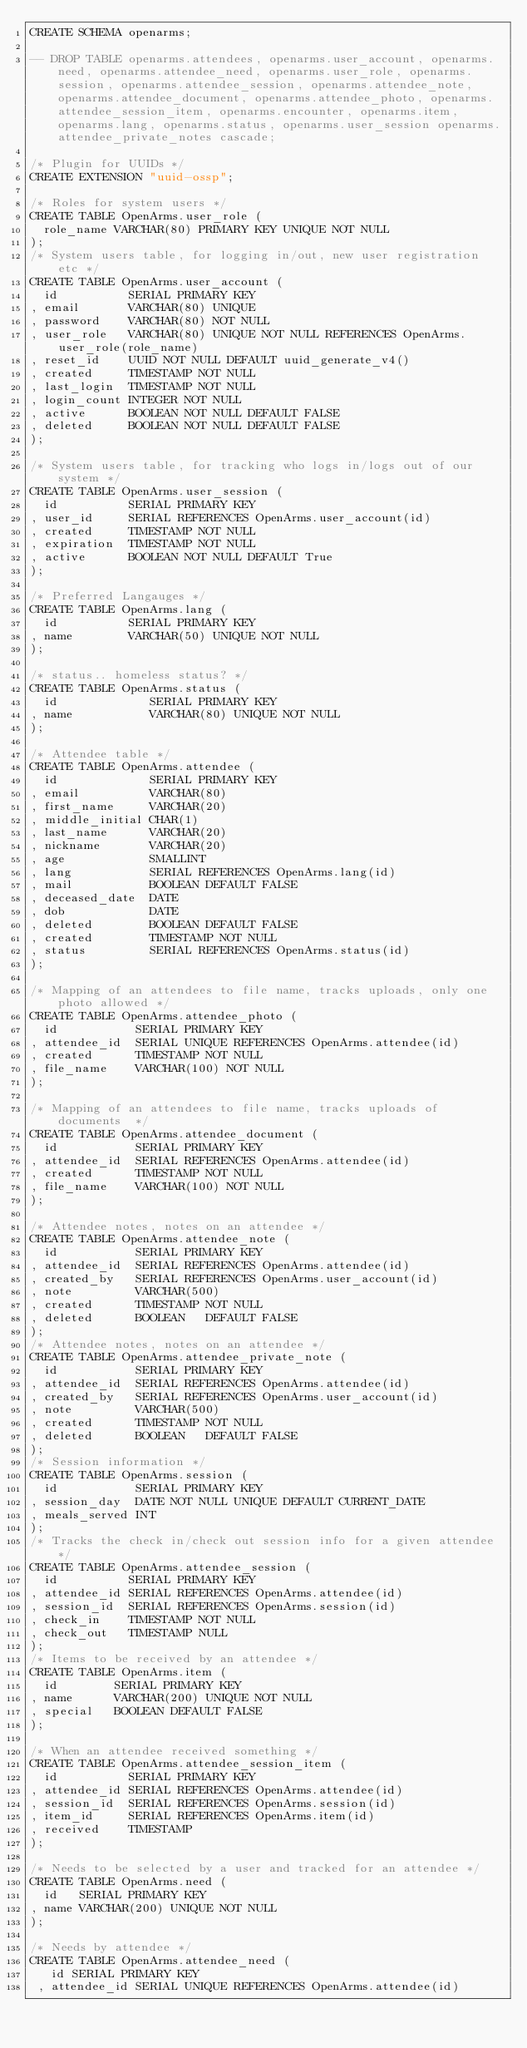Convert code to text. <code><loc_0><loc_0><loc_500><loc_500><_SQL_>CREATE SCHEMA openarms;

-- DROP TABLE openarms.attendees, openarms.user_account, openarms.need, openarms.attendee_need, openarms.user_role, openarms.session, openarms.attendee_session, openarms.attendee_note, openarms.attendee_document, openarms.attendee_photo, openarms.attendee_session_item, openarms.encounter, openarms.item, openarms.lang, openarms.status, openarms.user_session openarms.attendee_private_notes cascade;

/* Plugin for UUIDs */
CREATE EXTENSION "uuid-ossp";

/* Roles for system users */
CREATE TABLE OpenArms.user_role (
  role_name VARCHAR(80) PRIMARY KEY UNIQUE NOT NULL
);
/* System users table, for logging in/out, new user registration etc */
CREATE TABLE OpenArms.user_account (
  id          SERIAL PRIMARY KEY
, email       VARCHAR(80) UNIQUE
, password    VARCHAR(80) NOT NULL
, user_role   VARCHAR(80) UNIQUE NOT NULL REFERENCES OpenArms.user_role(role_name) 
, reset_id    UUID NOT NULL DEFAULT uuid_generate_v4()
, created     TIMESTAMP NOT NULL
, last_login  TIMESTAMP NOT NULL
, login_count INTEGER NOT NULL 
, active      BOOLEAN NOT NULL DEFAULT FALSE
, deleted     BOOLEAN NOT NULL DEFAULT FALSE
);

/* System users table, for tracking who logs in/logs out of our system */
CREATE TABLE OpenArms.user_session (
  id          SERIAL PRIMARY KEY
, user_id     SERIAL REFERENCES OpenArms.user_account(id)
, created     TIMESTAMP NOT NULL
, expiration  TIMESTAMP NOT NULL
, active      BOOLEAN NOT NULL DEFAULT True
);

/* Preferred Langauges */
CREATE TABLE OpenArms.lang (
  id          SERIAL PRIMARY KEY
, name        VARCHAR(50) UNIQUE NOT NULL
);

/* status.. homeless status? */ 
CREATE TABLE OpenArms.status (
  id             SERIAL PRIMARY KEY 
, name           VARCHAR(80) UNIQUE NOT NULL
);

/* Attendee table */
CREATE TABLE OpenArms.attendee (
  id             SERIAL PRIMARY KEY 
, email          VARCHAR(80) 
, first_name     VARCHAR(20) 
, middle_initial CHAR(1) 
, last_name      VARCHAR(20) 
, nickname       VARCHAR(20) 
, age            SMALLINT
, lang           SERIAL REFERENCES OpenArms.lang(id)
, mail           BOOLEAN DEFAULT FALSE
, deceased_date  DATE
, dob            DATE 
, deleted        BOOLEAN DEFAULT FALSE
, created        TIMESTAMP NOT NULL
, status         SERIAL REFERENCES OpenArms.status(id)
);

/* Mapping of an attendees to file name, tracks uploads, only one photo allowed */
CREATE TABLE OpenArms.attendee_photo (
  id           SERIAL PRIMARY KEY
, attendee_id  SERIAL UNIQUE REFERENCES OpenArms.attendee(id)
, created      TIMESTAMP NOT NULL
, file_name    VARCHAR(100) NOT NULL
);

/* Mapping of an attendees to file name, tracks uploads of documents  */
CREATE TABLE OpenArms.attendee_document (
  id           SERIAL PRIMARY KEY
, attendee_id  SERIAL REFERENCES OpenArms.attendee(id)
, created      TIMESTAMP NOT NULL
, file_name    VARCHAR(100) NOT NULL
);

/* Attendee notes, notes on an attendee */
CREATE TABLE OpenArms.attendee_note (
  id           SERIAL PRIMARY KEY
, attendee_id  SERIAL REFERENCES OpenArms.attendee(id)
, created_by   SERIAL REFERENCES OpenArms.user_account(id)
, note         VARCHAR(500) 
, created      TIMESTAMP NOT NULL
, deleted      BOOLEAN   DEFAULT FALSE
);
/* Attendee notes, notes on an attendee */
CREATE TABLE OpenArms.attendee_private_note (
  id           SERIAL PRIMARY KEY
, attendee_id  SERIAL REFERENCES OpenArms.attendee(id)
, created_by   SERIAL REFERENCES OpenArms.user_account(id)
, note         VARCHAR(500) 
, created      TIMESTAMP NOT NULL
, deleted      BOOLEAN   DEFAULT FALSE
);
/* Session information */
CREATE TABLE OpenArms.session (
  id           SERIAL PRIMARY KEY 
, session_day  DATE NOT NULL UNIQUE DEFAULT CURRENT_DATE
, meals_served INT 
);
/* Tracks the check in/check out session info for a given attendee */
CREATE TABLE OpenArms.attendee_session (
  id          SERIAL PRIMARY KEY 
, attendee_id SERIAL REFERENCES OpenArms.attendee(id)
, session_id  SERIAL REFERENCES OpenArms.session(id)
, check_in    TIMESTAMP NOT NULL
, check_out   TIMESTAMP NULL
);
/* Items to be received by an attendee */
CREATE TABLE OpenArms.item (
  id        SERIAL PRIMARY KEY 
, name      VARCHAR(200) UNIQUE NOT NULL
, special   BOOLEAN DEFAULT FALSE
);

/* When an attendee received something */
CREATE TABLE OpenArms.attendee_session_item (
  id          SERIAL PRIMARY KEY 
, attendee_id SERIAL REFERENCES OpenArms.attendee(id)
, session_id  SERIAL REFERENCES OpenArms.session(id)
, item_id     SERIAL REFERENCES OpenArms.item(id)
, received    TIMESTAMP
);

/* Needs to be selected by a user and tracked for an attendee */
CREATE TABLE OpenArms.need (
  id   SERIAL PRIMARY KEY 
, name VARCHAR(200) UNIQUE NOT NULL
);

/* Needs by attendee */
CREATE TABLE OpenArms.attendee_need (
   id SERIAL PRIMARY KEY
 , attendee_id SERIAL UNIQUE REFERENCES OpenArms.attendee(id)</code> 